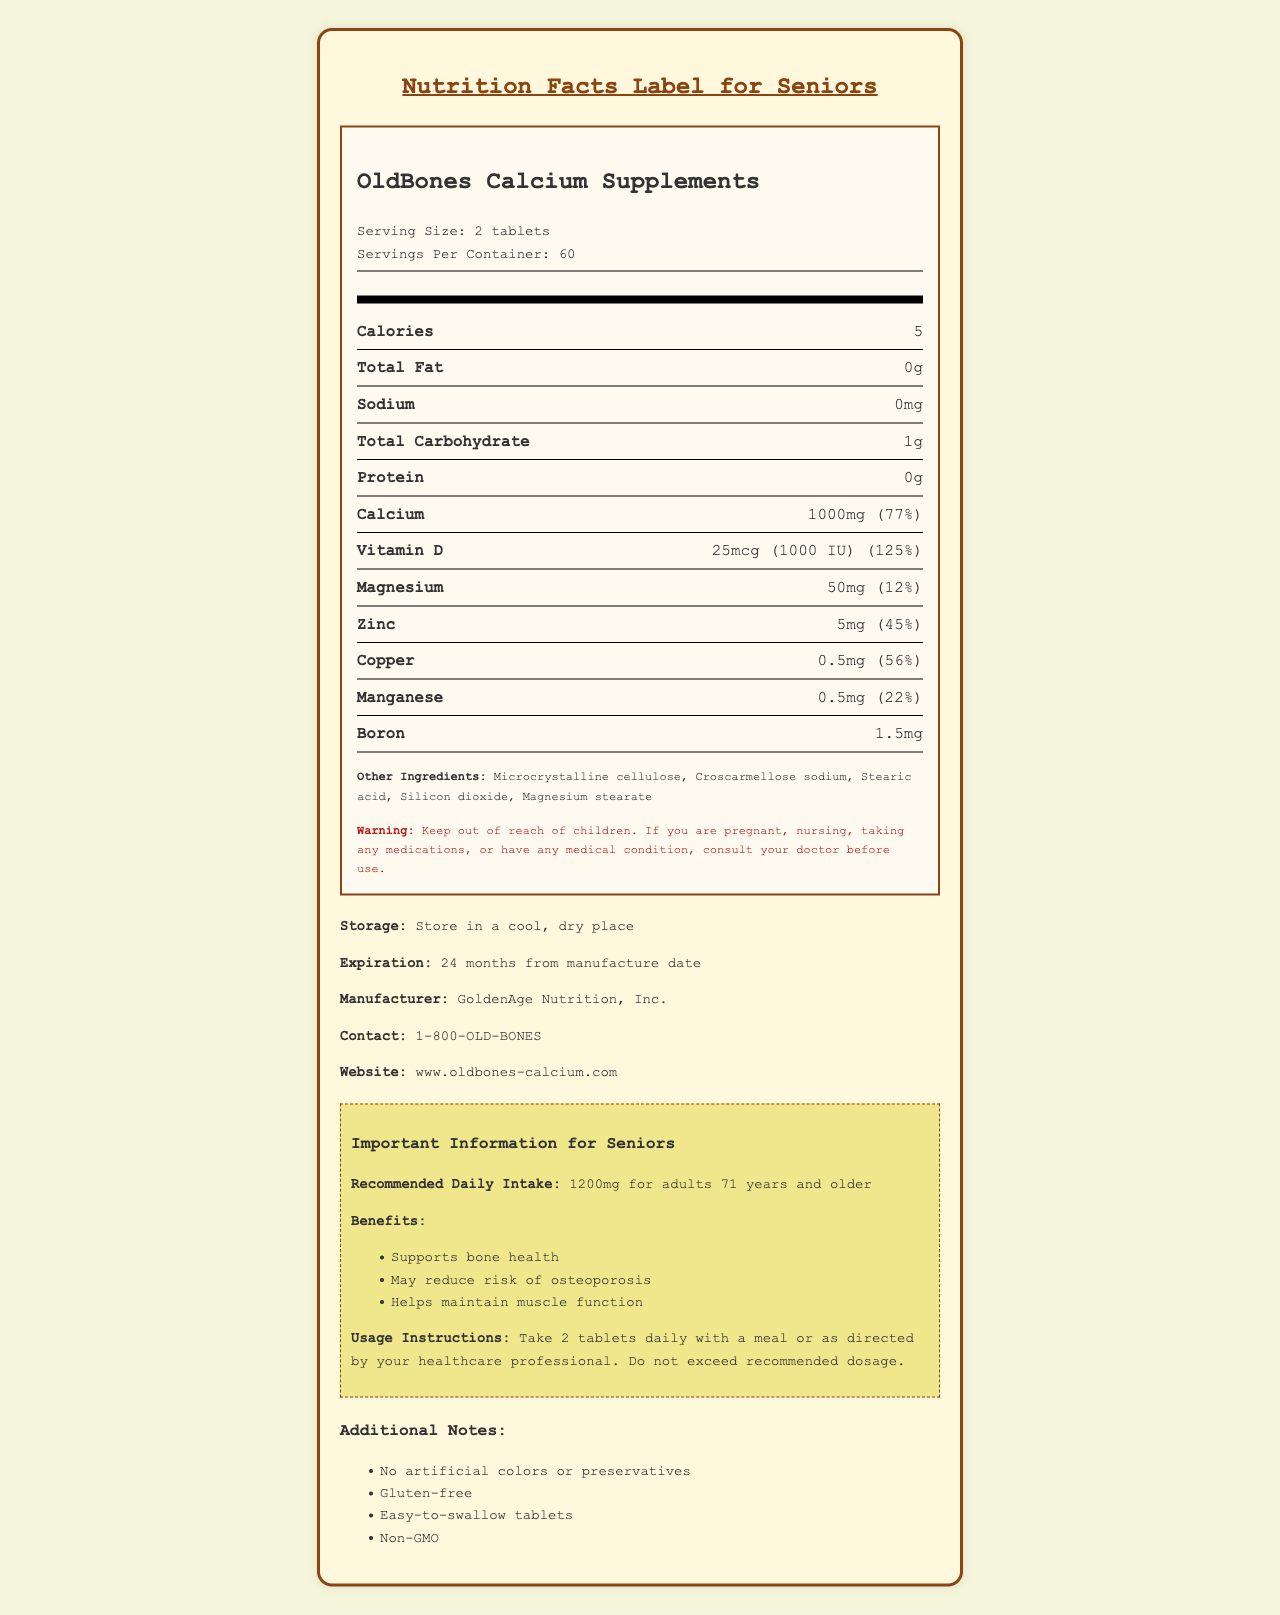what is the serving size of OldBones Calcium Supplements? The document states that the serving size is 2 tablets.
Answer: 2 tablets how many servings are there per container? The document specifies that there are 60 servings per container.
Answer: 60 how many calories are in a serving? According to the Nutrition Facts Label, each serving has 5 calories.
Answer: 5 calories what percentage of the Daily Value of calcium does a serving provide? The Nutrition Facts Label indicates that one serving provides 77% of the Daily Value for calcium.
Answer: 77% how much vitamin D is in each serving? The document lists that each serving contains 25mcg (1000 IU) of vitamin D.
Answer: 25mcg (1000 IU) which item is NOT an ingredient in the supplement? A. Microcrystalline cellulose B. Silicon dioxide C. Artificial colors D. Stearic acid The document states that artificial colors are not present in the list of ingredients.
Answer: C. Artificial colors how much % Daily Value of magnesium does a serving provide? A. 10% B. 12% C. 25% D. 45% The document indicates that each serving provides 12% of the Daily Value for magnesium.
Answer: B. 12% is this product suitable for children to consume without supervision? The document has a warning indicating to keep the product out of reach of children and to consult a doctor if children are to use it.
Answer: No what is the recommended daily intake of calcium for adults 71 years and older? The section specific to seniors suggests that the recommended daily intake is 1200mg for adults 71 years and older.
Answer: 1200mg summarize the main idea of this document. It includes comprehensive information on nutrient quantities per serving, daily values, usage instructions, and benefits specifically for older adults.
Answer: The document provides the Nutrition Facts Label for OldBones Calcium Supplements, detailing serving size, nutrient content, ingredients, warnings, and specific recommendations for seniors. what is the contact phone number for the manufacturer? The document lists the contact number as 1-800-OLD-BONES under the manufacturer's information.
Answer: 1-800-OLD-BONES how many additional notes are mentioned in the document? The document includes four additional notes: No artificial colors or preservatives, Gluten-free, Easy-to-swallow tablets, Non-GMO.
Answer: 4 what kind of place should the supplement be stored in? The document advises storing the product in a cool, dry place to maintain its efficacy.
Answer: A cool, dry place how long is the shelf life of the supplement from the manufacture date? The document mentions that the product has an expiration date of 24 months from the manufacture date.
Answer: 24 months how much zinc is in each serving of OldBones Calcium Supplements? According to the label, each serving contains 5mg of zinc.
Answer: 5mg what benefits does the supplement offer specifically for seniors? The senior-specific section lists these three benefits for older adults.
Answer: Supports bone health, May reduce risk of osteoporosis, Helps maintain muscle function what is the importance of consulting a doctor before using this supplement? The warning section specifies the importance of consulting a doctor under certain conditions.
Answer: If you are pregnant, nursing, taking any medications, or have any medical condition, consult your doctor before use does the document mention if the tablets are flavored? The document does not specifically mention if the tablets are flavored.
Answer: Not enough information 